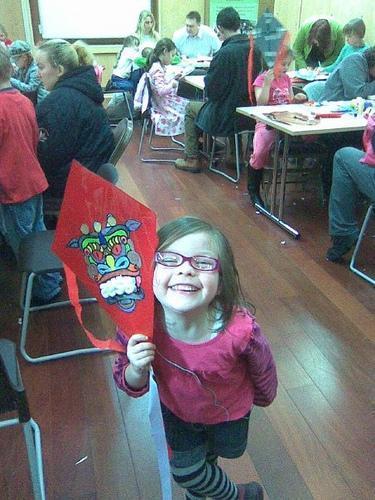How many kids are holding kites?
Give a very brief answer. 2. How many people are wearing glasses?
Give a very brief answer. 1. 